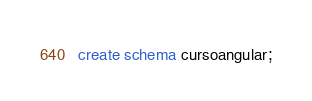Convert code to text. <code><loc_0><loc_0><loc_500><loc_500><_SQL_>create schema cursoangular;</code> 